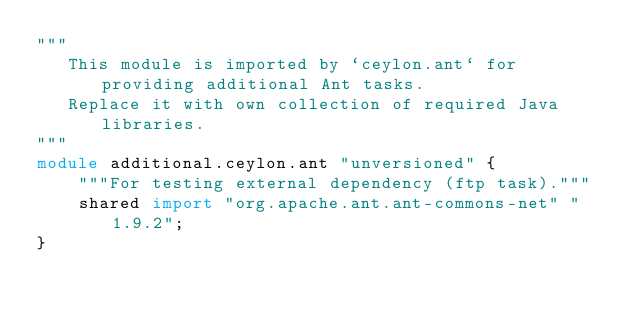Convert code to text. <code><loc_0><loc_0><loc_500><loc_500><_Ceylon_>"""
   This module is imported by `ceylon.ant` for providing additional Ant tasks.
   Replace it with own collection of required Java libraries.  
"""
module additional.ceylon.ant "unversioned" {
    """For testing external dependency (ftp task)."""
    shared import "org.apache.ant.ant-commons-net" "1.9.2"; 
}
</code> 